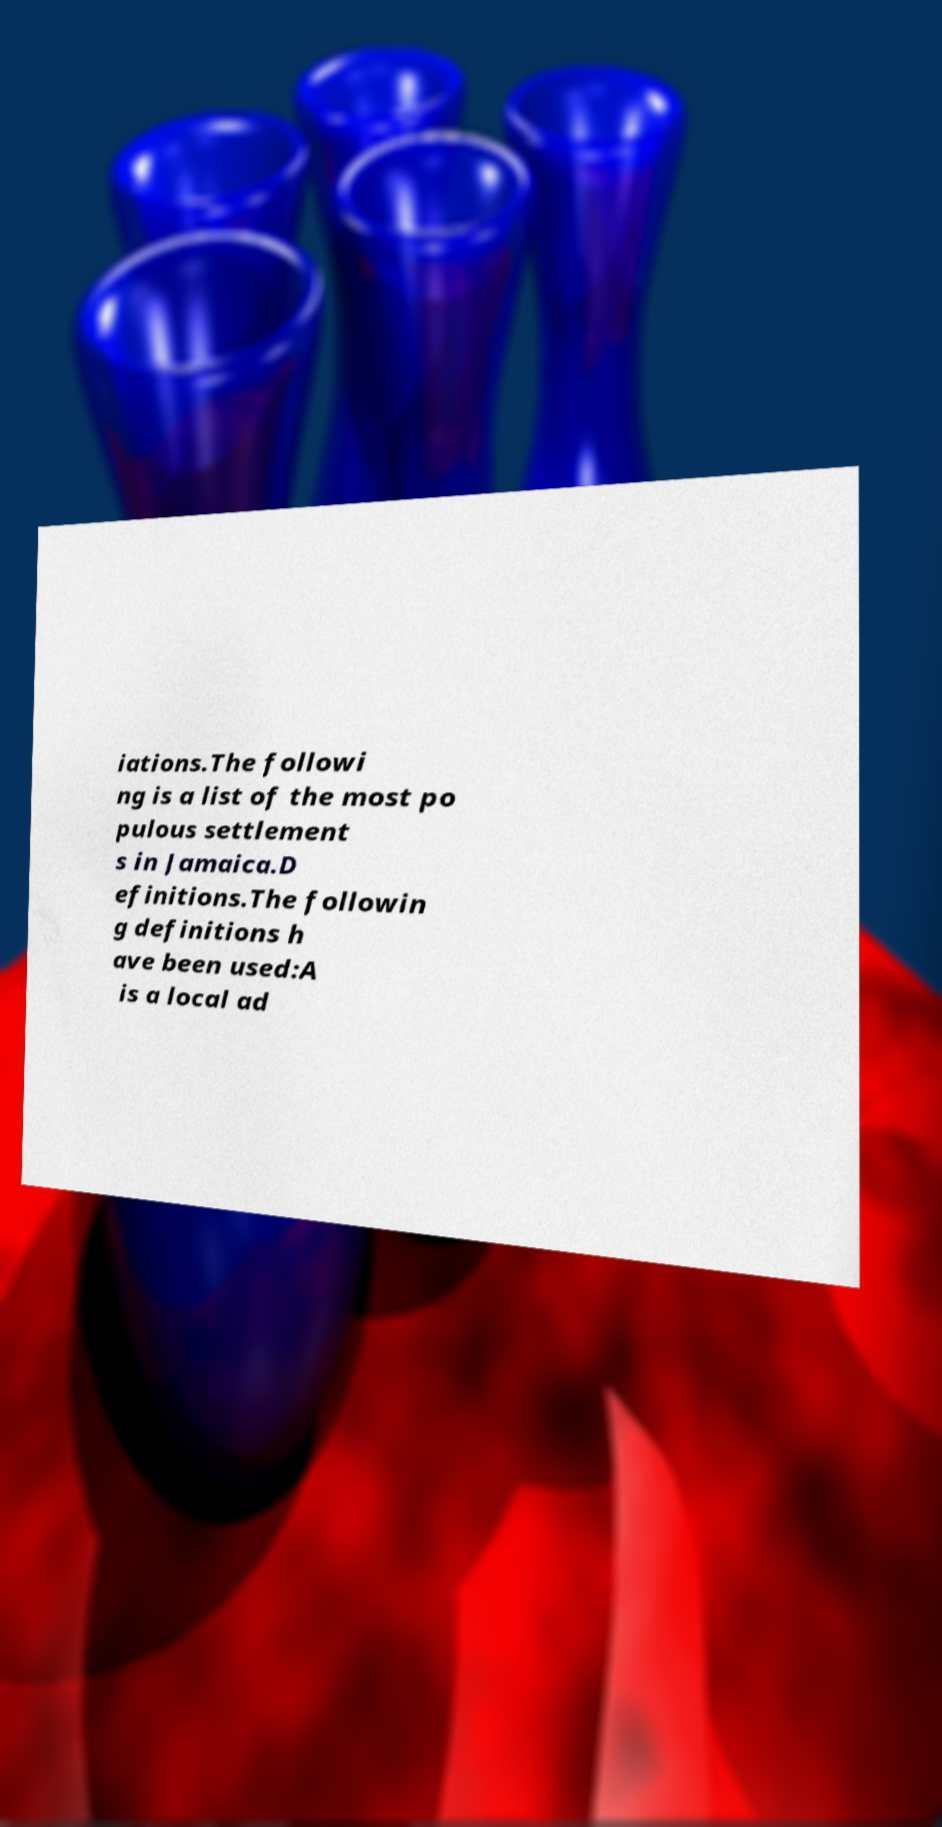Please read and relay the text visible in this image. What does it say? iations.The followi ng is a list of the most po pulous settlement s in Jamaica.D efinitions.The followin g definitions h ave been used:A is a local ad 